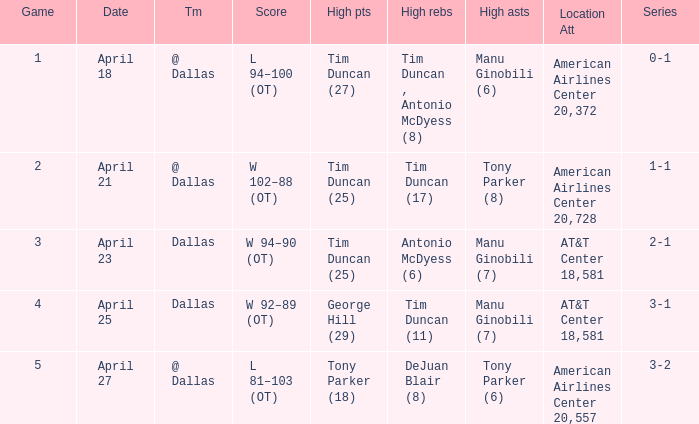Help me parse the entirety of this table. {'header': ['Game', 'Date', 'Tm', 'Score', 'High pts', 'High rebs', 'High asts', 'Location Att', 'Series'], 'rows': [['1', 'April 18', '@ Dallas', 'L 94–100 (OT)', 'Tim Duncan (27)', 'Tim Duncan , Antonio McDyess (8)', 'Manu Ginobili (6)', 'American Airlines Center 20,372', '0-1'], ['2', 'April 21', '@ Dallas', 'W 102–88 (OT)', 'Tim Duncan (25)', 'Tim Duncan (17)', 'Tony Parker (8)', 'American Airlines Center 20,728', '1-1'], ['3', 'April 23', 'Dallas', 'W 94–90 (OT)', 'Tim Duncan (25)', 'Antonio McDyess (6)', 'Manu Ginobili (7)', 'AT&T Center 18,581', '2-1'], ['4', 'April 25', 'Dallas', 'W 92–89 (OT)', 'George Hill (29)', 'Tim Duncan (11)', 'Manu Ginobili (7)', 'AT&T Center 18,581', '3-1'], ['5', 'April 27', '@ Dallas', 'L 81–103 (OT)', 'Tony Parker (18)', 'DeJuan Blair (8)', 'Tony Parker (6)', 'American Airlines Center 20,557', '3-2']]} When 1-1 is the series who is the team? @ Dallas. 